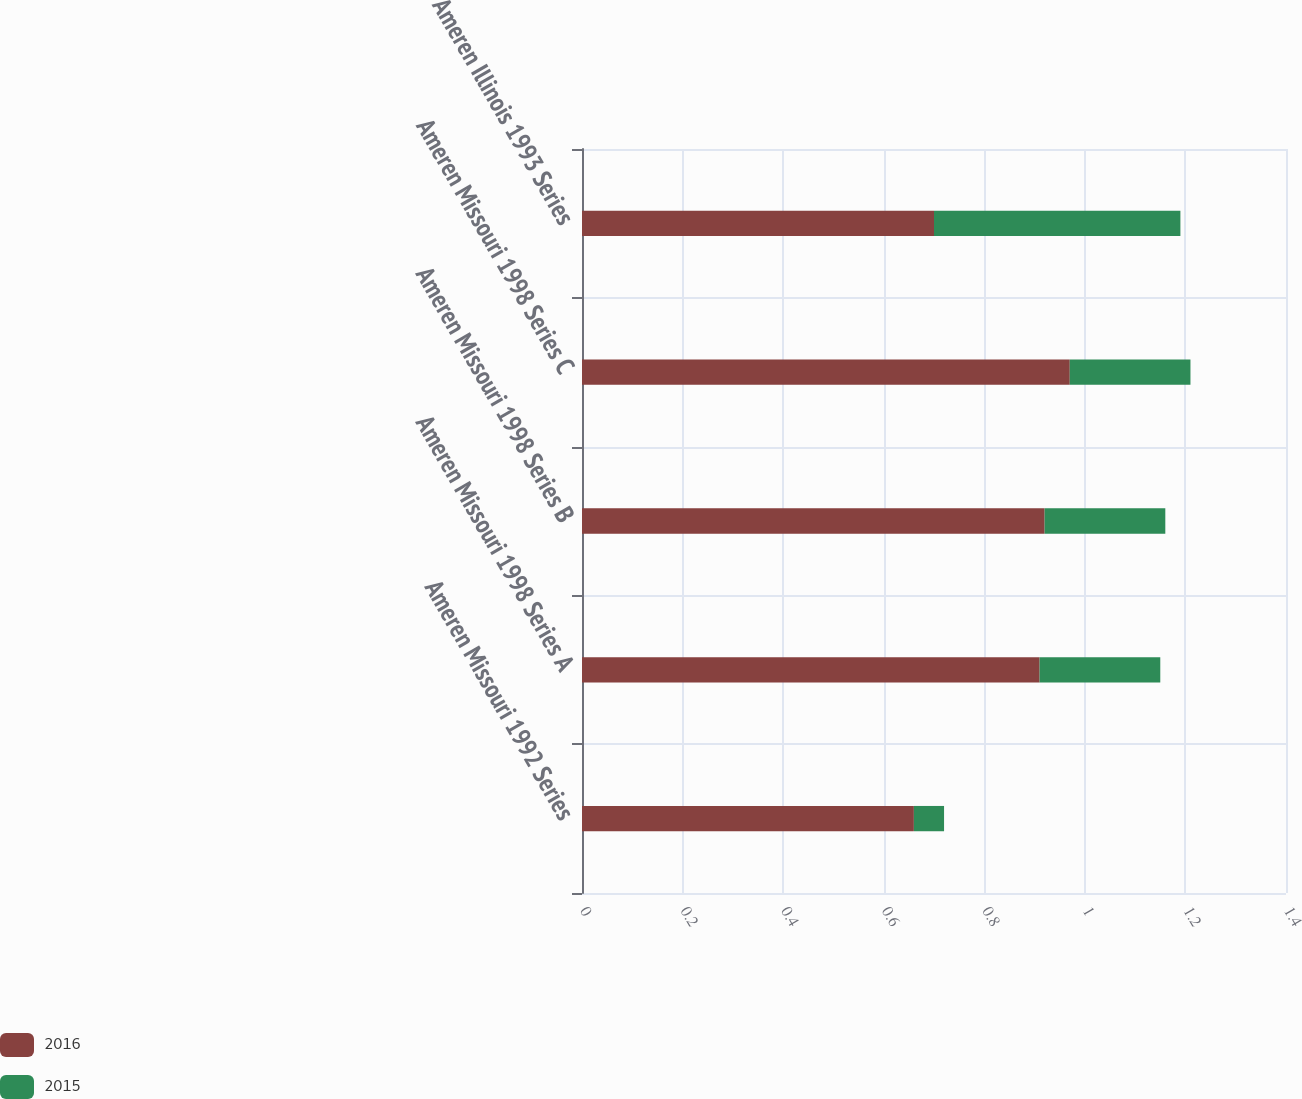Convert chart to OTSL. <chart><loc_0><loc_0><loc_500><loc_500><stacked_bar_chart><ecel><fcel>Ameren Missouri 1992 Series<fcel>Ameren Missouri 1998 Series A<fcel>Ameren Missouri 1998 Series B<fcel>Ameren Missouri 1998 Series C<fcel>Ameren Illinois 1993 Series<nl><fcel>2016<fcel>0.66<fcel>0.91<fcel>0.92<fcel>0.97<fcel>0.7<nl><fcel>2015<fcel>0.06<fcel>0.24<fcel>0.24<fcel>0.24<fcel>0.49<nl></chart> 